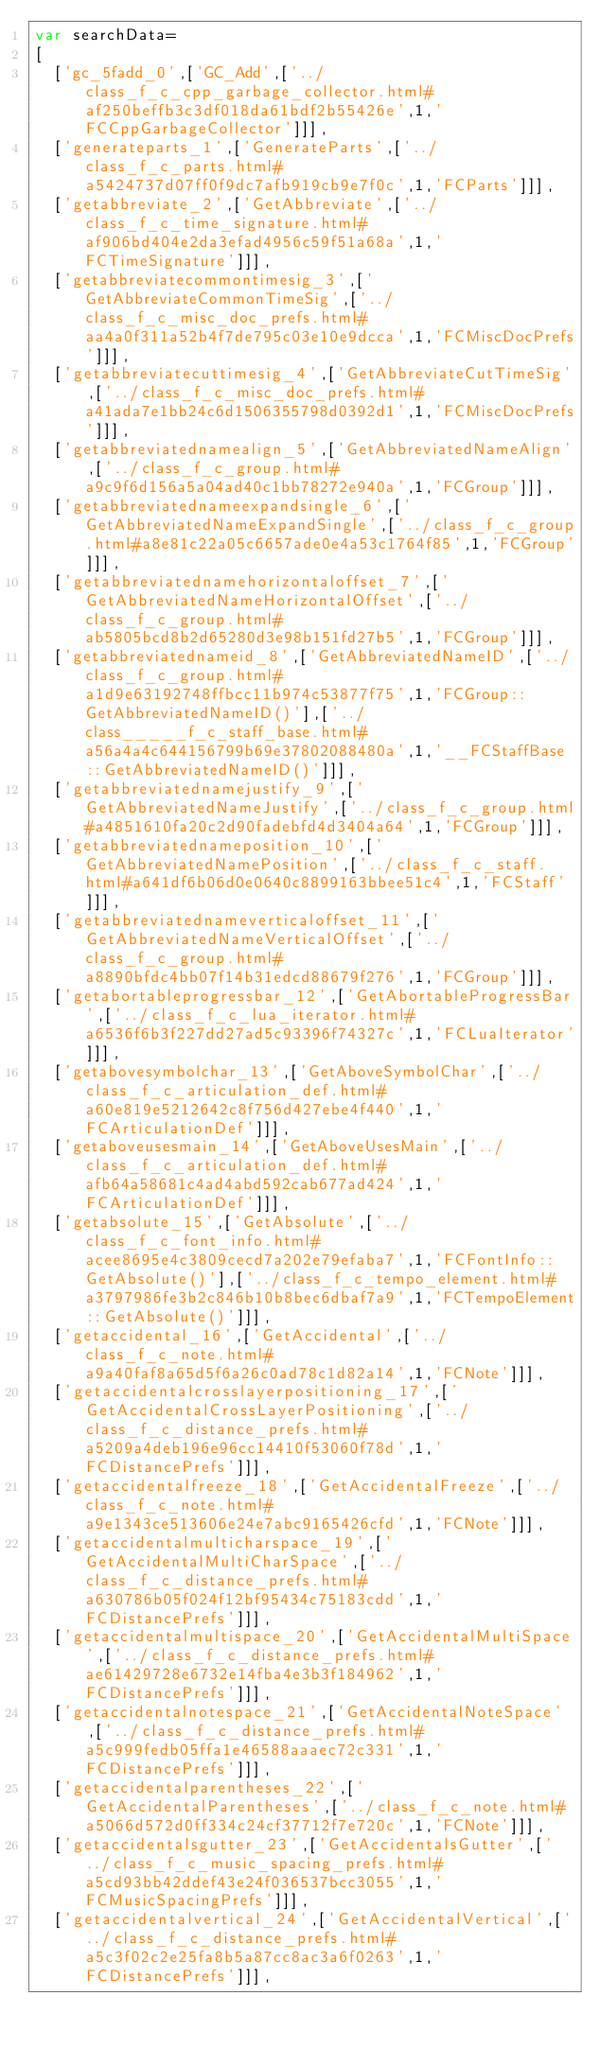Convert code to text. <code><loc_0><loc_0><loc_500><loc_500><_JavaScript_>var searchData=
[
  ['gc_5fadd_0',['GC_Add',['../class_f_c_cpp_garbage_collector.html#af250beffb3c3df018da61bdf2b55426e',1,'FCCppGarbageCollector']]],
  ['generateparts_1',['GenerateParts',['../class_f_c_parts.html#a5424737d07ff0f9dc7afb919cb9e7f0c',1,'FCParts']]],
  ['getabbreviate_2',['GetAbbreviate',['../class_f_c_time_signature.html#af906bd404e2da3efad4956c59f51a68a',1,'FCTimeSignature']]],
  ['getabbreviatecommontimesig_3',['GetAbbreviateCommonTimeSig',['../class_f_c_misc_doc_prefs.html#aa4a0f311a52b4f7de795c03e10e9dcca',1,'FCMiscDocPrefs']]],
  ['getabbreviatecuttimesig_4',['GetAbbreviateCutTimeSig',['../class_f_c_misc_doc_prefs.html#a41ada7e1bb24c6d1506355798d0392d1',1,'FCMiscDocPrefs']]],
  ['getabbreviatednamealign_5',['GetAbbreviatedNameAlign',['../class_f_c_group.html#a9c9f6d156a5a04ad40c1bb78272e940a',1,'FCGroup']]],
  ['getabbreviatednameexpandsingle_6',['GetAbbreviatedNameExpandSingle',['../class_f_c_group.html#a8e81c22a05c6657ade0e4a53c1764f85',1,'FCGroup']]],
  ['getabbreviatednamehorizontaloffset_7',['GetAbbreviatedNameHorizontalOffset',['../class_f_c_group.html#ab5805bcd8b2d65280d3e98b151fd27b5',1,'FCGroup']]],
  ['getabbreviatednameid_8',['GetAbbreviatedNameID',['../class_f_c_group.html#a1d9e63192748ffbcc11b974c53877f75',1,'FCGroup::GetAbbreviatedNameID()'],['../class_____f_c_staff_base.html#a56a4a4c644156799b69e37802088480a',1,'__FCStaffBase::GetAbbreviatedNameID()']]],
  ['getabbreviatednamejustify_9',['GetAbbreviatedNameJustify',['../class_f_c_group.html#a4851610fa20c2d90fadebfd4d3404a64',1,'FCGroup']]],
  ['getabbreviatednameposition_10',['GetAbbreviatedNamePosition',['../class_f_c_staff.html#a641df6b06d0e0640c8899163bbee51c4',1,'FCStaff']]],
  ['getabbreviatednameverticaloffset_11',['GetAbbreviatedNameVerticalOffset',['../class_f_c_group.html#a8890bfdc4bb07f14b31edcd88679f276',1,'FCGroup']]],
  ['getabortableprogressbar_12',['GetAbortableProgressBar',['../class_f_c_lua_iterator.html#a6536f6b3f227dd27ad5c93396f74327c',1,'FCLuaIterator']]],
  ['getabovesymbolchar_13',['GetAboveSymbolChar',['../class_f_c_articulation_def.html#a60e819e5212642c8f756d427ebe4f440',1,'FCArticulationDef']]],
  ['getaboveusesmain_14',['GetAboveUsesMain',['../class_f_c_articulation_def.html#afb64a58681c4ad4abd592cab677ad424',1,'FCArticulationDef']]],
  ['getabsolute_15',['GetAbsolute',['../class_f_c_font_info.html#acee8695e4c3809cecd7a202e79efaba7',1,'FCFontInfo::GetAbsolute()'],['../class_f_c_tempo_element.html#a3797986fe3b2c846b10b8bec6dbaf7a9',1,'FCTempoElement::GetAbsolute()']]],
  ['getaccidental_16',['GetAccidental',['../class_f_c_note.html#a9a40faf8a65d5f6a26c0ad78c1d82a14',1,'FCNote']]],
  ['getaccidentalcrosslayerpositioning_17',['GetAccidentalCrossLayerPositioning',['../class_f_c_distance_prefs.html#a5209a4deb196e96cc14410f53060f78d',1,'FCDistancePrefs']]],
  ['getaccidentalfreeze_18',['GetAccidentalFreeze',['../class_f_c_note.html#a9e1343ce513606e24e7abc9165426cfd',1,'FCNote']]],
  ['getaccidentalmulticharspace_19',['GetAccidentalMultiCharSpace',['../class_f_c_distance_prefs.html#a630786b05f024f12bf95434c75183cdd',1,'FCDistancePrefs']]],
  ['getaccidentalmultispace_20',['GetAccidentalMultiSpace',['../class_f_c_distance_prefs.html#ae61429728e6732e14fba4e3b3f184962',1,'FCDistancePrefs']]],
  ['getaccidentalnotespace_21',['GetAccidentalNoteSpace',['../class_f_c_distance_prefs.html#a5c999fedb05ffa1e46588aaaec72c331',1,'FCDistancePrefs']]],
  ['getaccidentalparentheses_22',['GetAccidentalParentheses',['../class_f_c_note.html#a5066d572d0ff334c24cf37712f7e720c',1,'FCNote']]],
  ['getaccidentalsgutter_23',['GetAccidentalsGutter',['../class_f_c_music_spacing_prefs.html#a5cd93bb42ddef43e24f036537bcc3055',1,'FCMusicSpacingPrefs']]],
  ['getaccidentalvertical_24',['GetAccidentalVertical',['../class_f_c_distance_prefs.html#a5c3f02c2e25fa8b5a87cc8ac3a6f0263',1,'FCDistancePrefs']]],</code> 